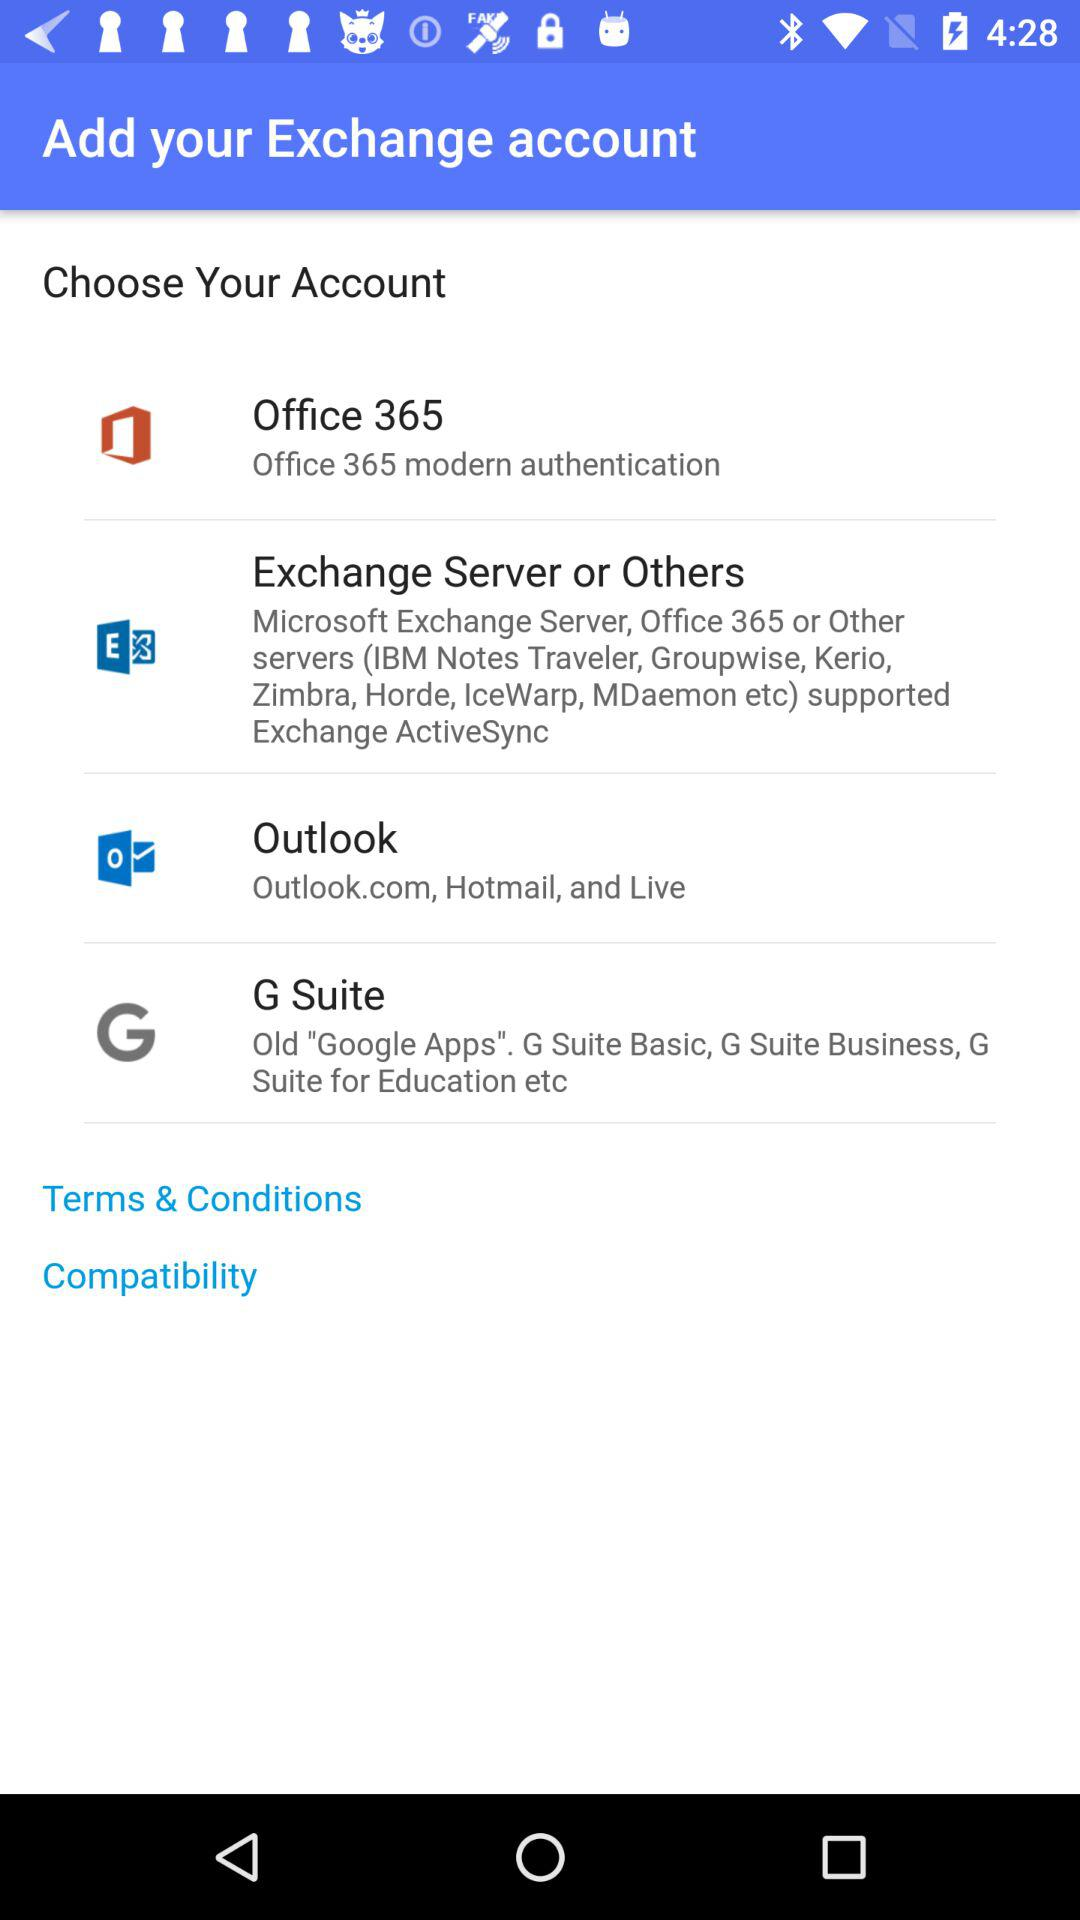How many account types are there?
Answer the question using a single word or phrase. 4 